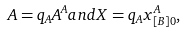<formula> <loc_0><loc_0><loc_500><loc_500>A = q _ { A } A ^ { A } a n d X = q _ { A } x ^ { A } _ { [ B ] 0 } ,</formula> 